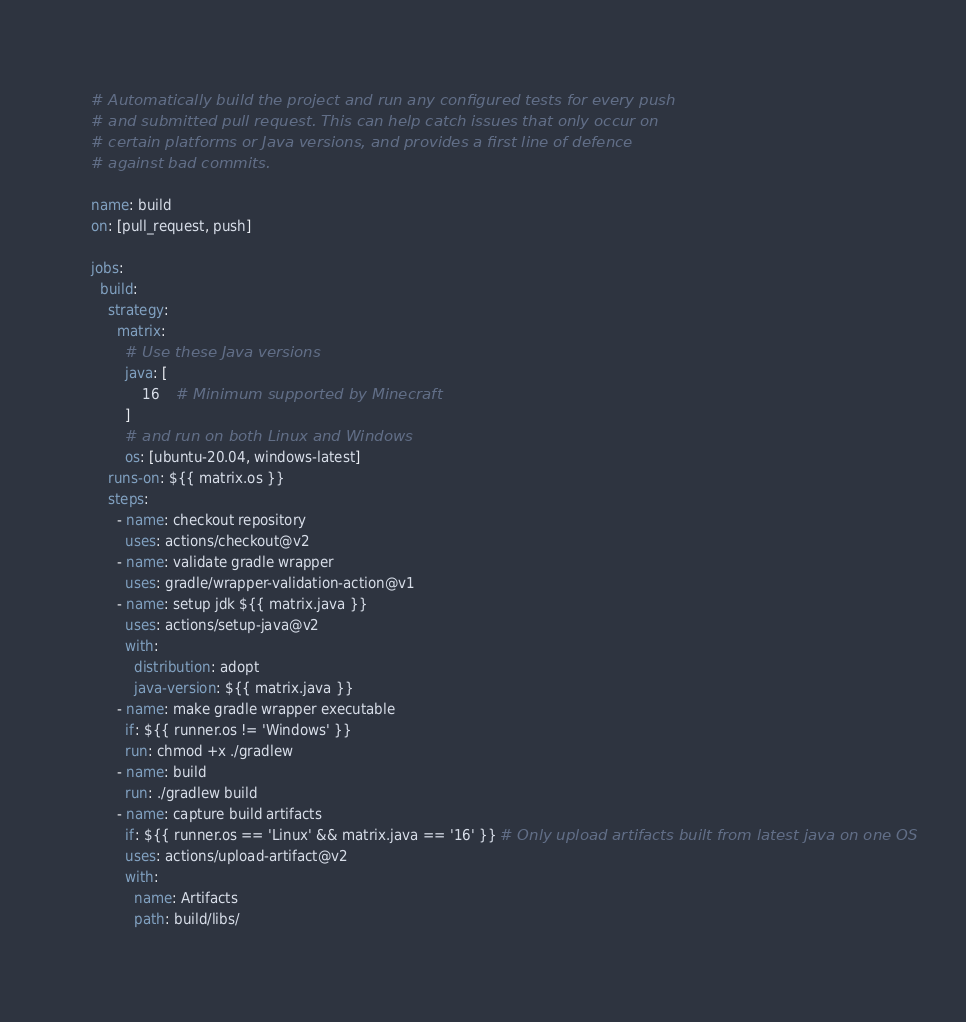Convert code to text. <code><loc_0><loc_0><loc_500><loc_500><_YAML_># Automatically build the project and run any configured tests for every push
# and submitted pull request. This can help catch issues that only occur on
# certain platforms or Java versions, and provides a first line of defence
# against bad commits.

name: build
on: [pull_request, push]

jobs:
  build:
    strategy:
      matrix:
        # Use these Java versions
        java: [
            16    # Minimum supported by Minecraft
        ]
        # and run on both Linux and Windows
        os: [ubuntu-20.04, windows-latest]
    runs-on: ${{ matrix.os }}
    steps:
      - name: checkout repository
        uses: actions/checkout@v2
      - name: validate gradle wrapper
        uses: gradle/wrapper-validation-action@v1
      - name: setup jdk ${{ matrix.java }}
        uses: actions/setup-java@v2
        with:
          distribution: adopt
          java-version: ${{ matrix.java }}
      - name: make gradle wrapper executable
        if: ${{ runner.os != 'Windows' }}
        run: chmod +x ./gradlew
      - name: build
        run: ./gradlew build
      - name: capture build artifacts
        if: ${{ runner.os == 'Linux' && matrix.java == '16' }} # Only upload artifacts built from latest java on one OS
        uses: actions/upload-artifact@v2
        with:
          name: Artifacts
          path: build/libs/
</code> 